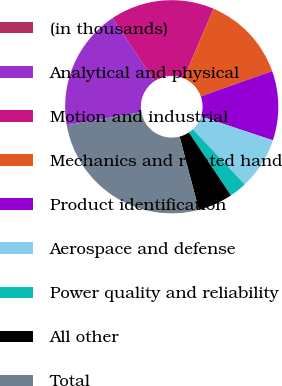Convert chart to OTSL. <chart><loc_0><loc_0><loc_500><loc_500><pie_chart><fcel>(in thousands)<fcel>Analytical and physical<fcel>Motion and industrial<fcel>Mechanics and related hand<fcel>Product identification<fcel>Aerospace and defense<fcel>Power quality and reliability<fcel>All other<fcel>Total<nl><fcel>0.01%<fcel>18.42%<fcel>15.79%<fcel>13.16%<fcel>10.53%<fcel>7.9%<fcel>2.64%<fcel>5.27%<fcel>26.31%<nl></chart> 